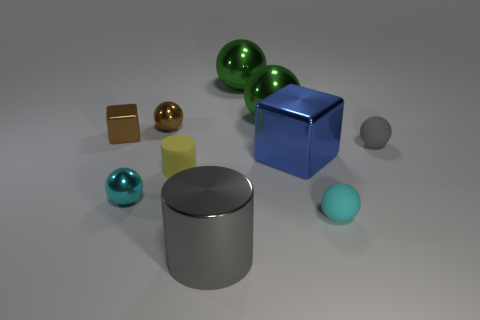How does the lighting in this scene affect the appearance of the objects? The scene is lit in such a way that soft shadows are cast onto the surface beneath the objects, giving depth and dimension to the arrangement. The lighting accentuates the reflective properties of the metallic spheres and the cylinder, creating highlights and reflected colors, while the matte surfaces of the cubes demonstrate less intense reflections, contributing to the discernment of their different materials. 